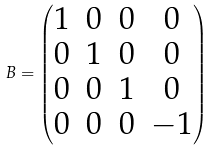Convert formula to latex. <formula><loc_0><loc_0><loc_500><loc_500>B = \begin{pmatrix} 1 & 0 & 0 & 0 \\ 0 & 1 & 0 & 0 \\ 0 & 0 & 1 & 0 \\ 0 & 0 & 0 & - 1 \end{pmatrix}</formula> 